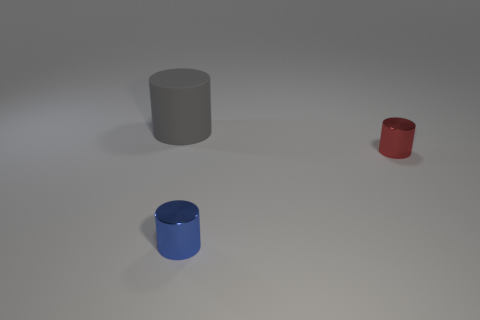Are there any other things that are the same size as the gray rubber object?
Your answer should be compact. No. What size is the metallic object behind the blue thing?
Keep it short and to the point. Small. There is a gray cylinder that is behind the metallic cylinder that is behind the small blue metallic object; what number of small blue metal cylinders are in front of it?
Your answer should be very brief. 1. There is a small red cylinder; are there any small metal cylinders in front of it?
Offer a very short reply. Yes. What number of other things are there of the same size as the rubber cylinder?
Offer a terse response. 0. There is a thing that is behind the blue shiny cylinder and left of the red object; what material is it?
Ensure brevity in your answer.  Rubber. Does the metallic object on the left side of the tiny red metallic cylinder have the same shape as the small object that is behind the tiny blue metallic cylinder?
Offer a very short reply. Yes. Is there any other thing that has the same material as the gray cylinder?
Your response must be concise. No. What is the shape of the shiny thing that is on the left side of the tiny object right of the thing that is in front of the small red metallic cylinder?
Keep it short and to the point. Cylinder. How many other objects are there of the same shape as the small red shiny thing?
Ensure brevity in your answer.  2. 